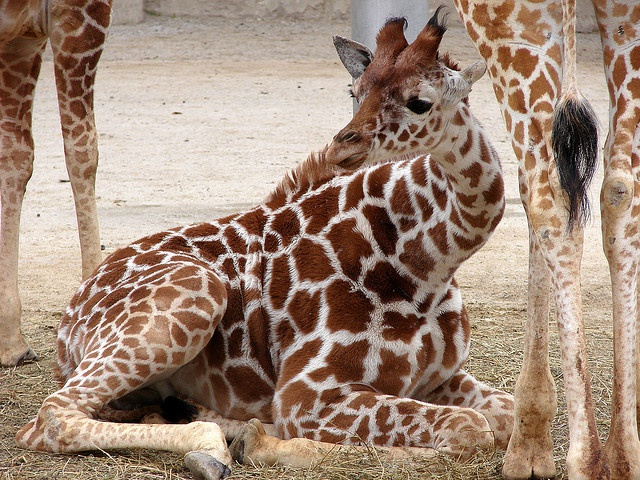Describe the objects in this image and their specific colors. I can see giraffe in maroon, gray, darkgray, and black tones, giraffe in maroon, gray, tan, and darkgray tones, and giraffe in maroon, gray, tan, and brown tones in this image. 